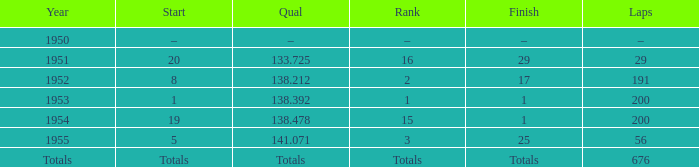What ranking that had a start of 19? 15.0. 